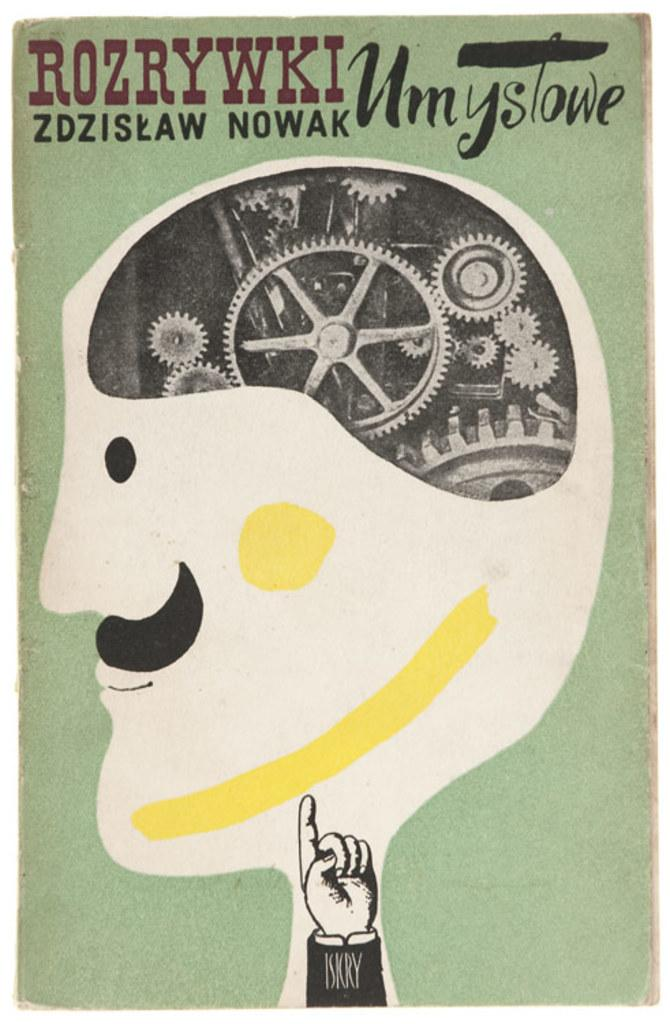Provide a one-sentence caption for the provided image. An image of a mustached man with gears in his head is printed with "Rozrywki zdziskaw Nowak" and "Umystowe". 